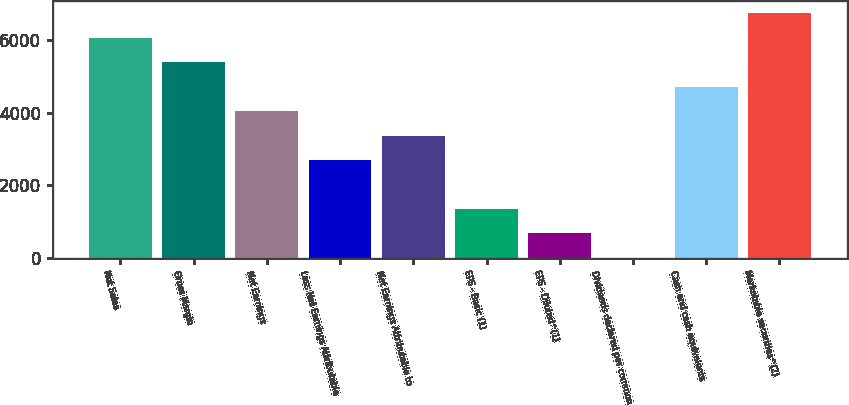Convert chart. <chart><loc_0><loc_0><loc_500><loc_500><bar_chart><fcel>Net Sales<fcel>Gross Margin<fcel>Net Earnings<fcel>Less Net Earnings Attributable<fcel>Net Earnings Attributable to<fcel>EPS - Basic (1)<fcel>EPS - Diluted^(1)<fcel>Dividends declared per common<fcel>Cash and cash equivalents<fcel>Marketable securities^(2)<nl><fcel>6065.16<fcel>5391.29<fcel>4043.55<fcel>2695.81<fcel>3369.68<fcel>1348.07<fcel>674.2<fcel>0.33<fcel>4717.42<fcel>6739.03<nl></chart> 